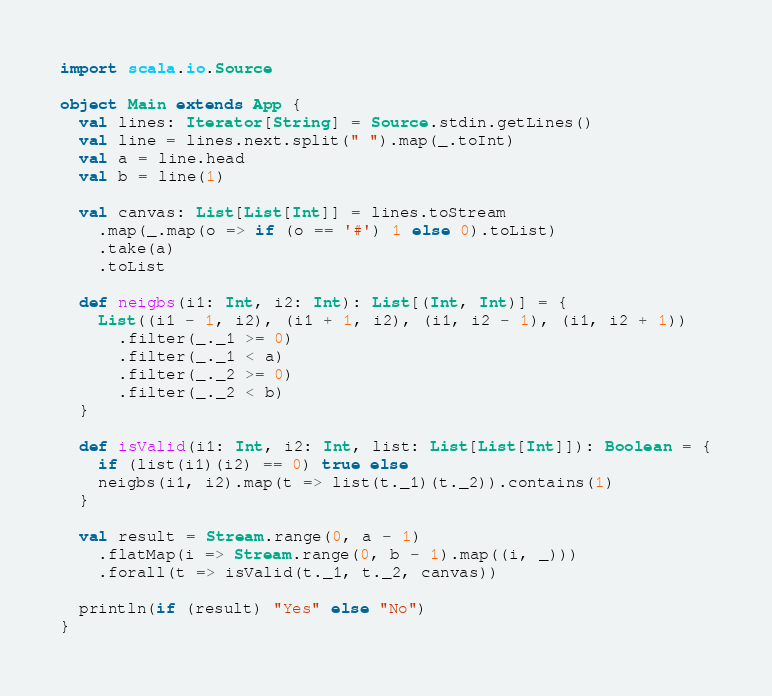<code> <loc_0><loc_0><loc_500><loc_500><_Scala_>import scala.io.Source

object Main extends App {
  val lines: Iterator[String] = Source.stdin.getLines()
  val line = lines.next.split(" ").map(_.toInt)
  val a = line.head
  val b = line(1)

  val canvas: List[List[Int]] = lines.toStream
    .map(_.map(o => if (o == '#') 1 else 0).toList)
    .take(a)
    .toList

  def neigbs(i1: Int, i2: Int): List[(Int, Int)] = {
    List((i1 - 1, i2), (i1 + 1, i2), (i1, i2 - 1), (i1, i2 + 1))
      .filter(_._1 >= 0)
      .filter(_._1 < a)
      .filter(_._2 >= 0)
      .filter(_._2 < b)
  }

  def isValid(i1: Int, i2: Int, list: List[List[Int]]): Boolean = {
    if (list(i1)(i2) == 0) true else
    neigbs(i1, i2).map(t => list(t._1)(t._2)).contains(1)
  }

  val result = Stream.range(0, a - 1)
    .flatMap(i => Stream.range(0, b - 1).map((i, _)))
    .forall(t => isValid(t._1, t._2, canvas))

  println(if (result) "Yes" else "No")
}
</code> 